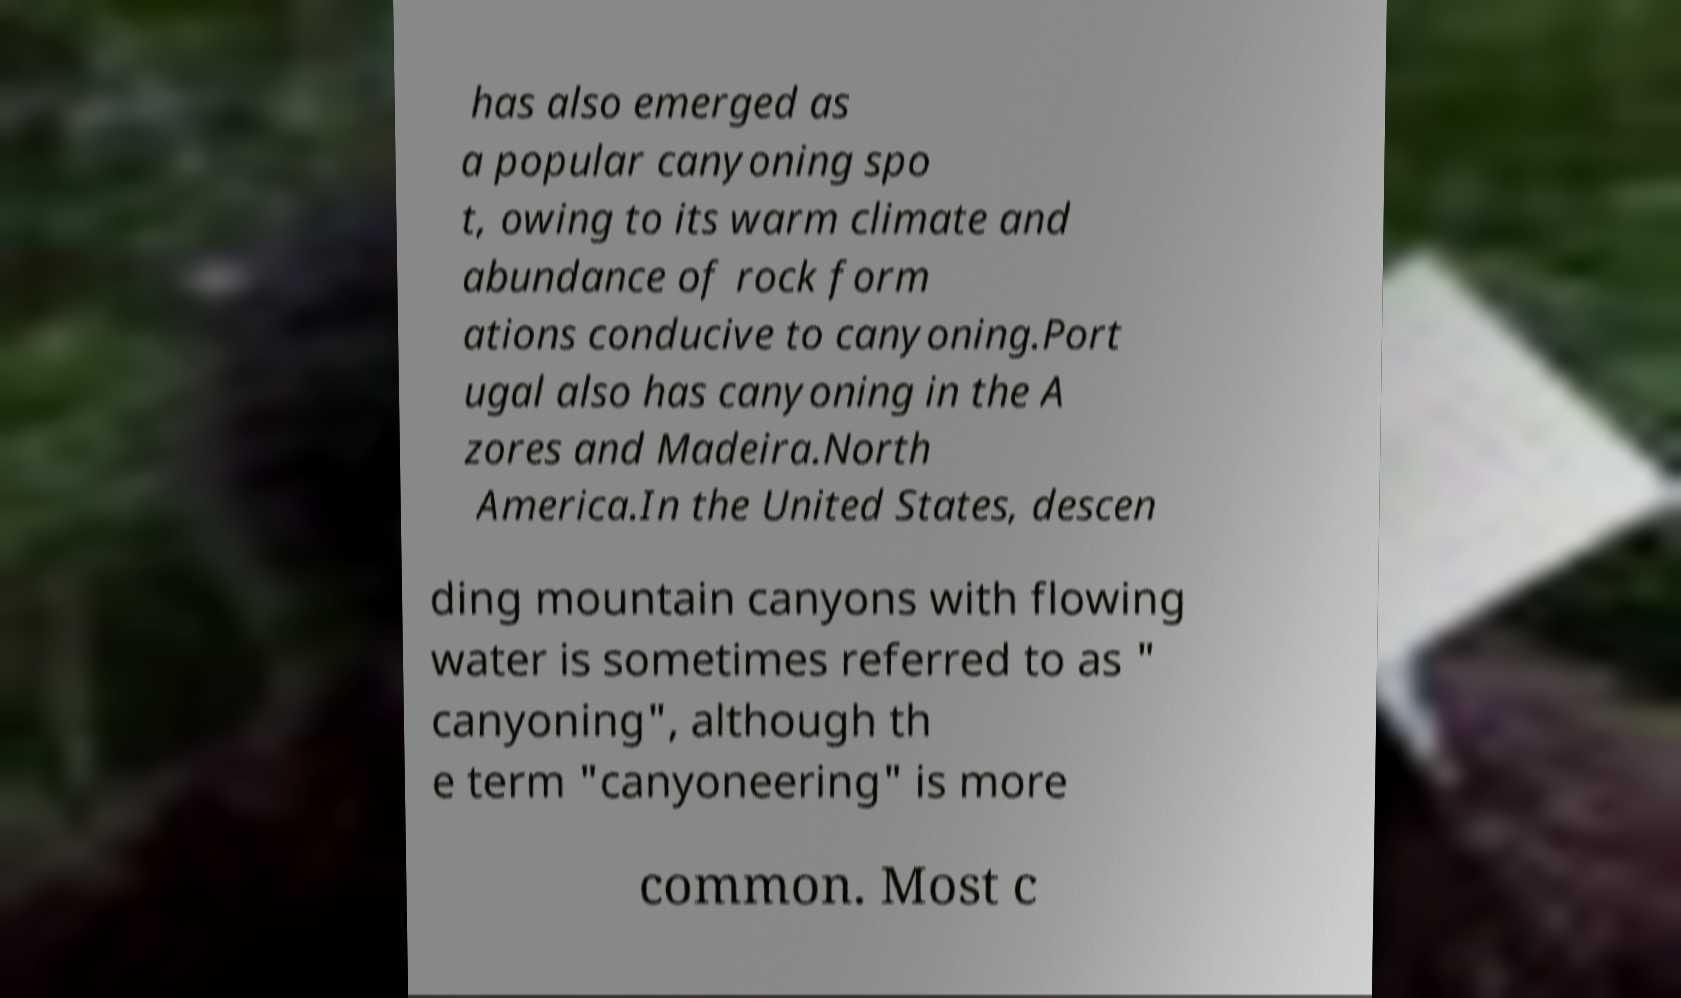What messages or text are displayed in this image? I need them in a readable, typed format. has also emerged as a popular canyoning spo t, owing to its warm climate and abundance of rock form ations conducive to canyoning.Port ugal also has canyoning in the A zores and Madeira.North America.In the United States, descen ding mountain canyons with flowing water is sometimes referred to as " canyoning", although th e term "canyoneering" is more common. Most c 